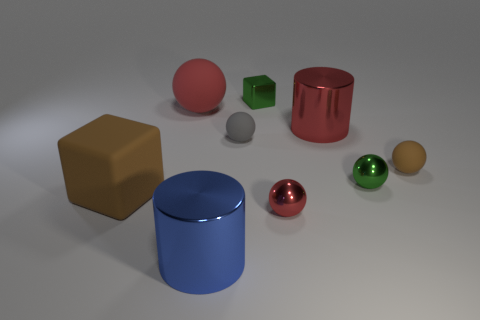What size is the metallic cylinder that is the same color as the large matte ball?
Keep it short and to the point. Large. What size is the red thing that is made of the same material as the small gray thing?
Give a very brief answer. Large. There is a large rubber sphere; does it have the same color as the large metal object that is behind the tiny brown matte sphere?
Provide a succinct answer. Yes. How many other objects are the same color as the matte cube?
Ensure brevity in your answer.  1. How many small red spheres are there?
Make the answer very short. 1. Is the number of cubes that are right of the large red cylinder less than the number of red shiny spheres?
Offer a terse response. Yes. Do the brown thing to the left of the brown rubber sphere and the small brown sphere have the same material?
Offer a very short reply. Yes. What is the shape of the brown matte thing that is behind the matte thing left of the large red thing to the left of the tiny gray object?
Provide a short and direct response. Sphere. Is there a gray object that has the same size as the red metal sphere?
Give a very brief answer. Yes. How big is the gray sphere?
Provide a short and direct response. Small. 